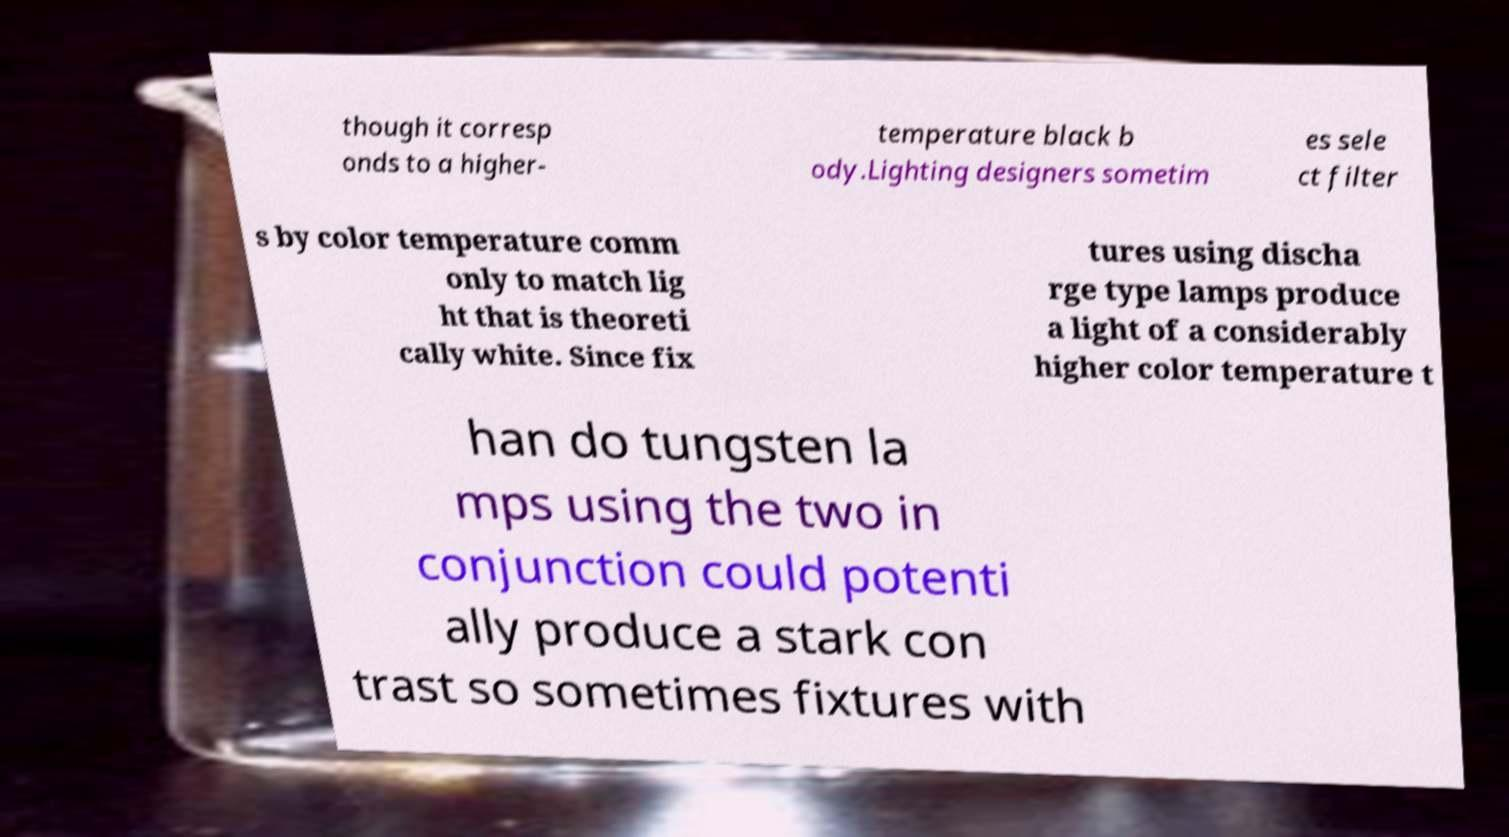There's text embedded in this image that I need extracted. Can you transcribe it verbatim? though it corresp onds to a higher- temperature black b ody.Lighting designers sometim es sele ct filter s by color temperature comm only to match lig ht that is theoreti cally white. Since fix tures using discha rge type lamps produce a light of a considerably higher color temperature t han do tungsten la mps using the two in conjunction could potenti ally produce a stark con trast so sometimes fixtures with 